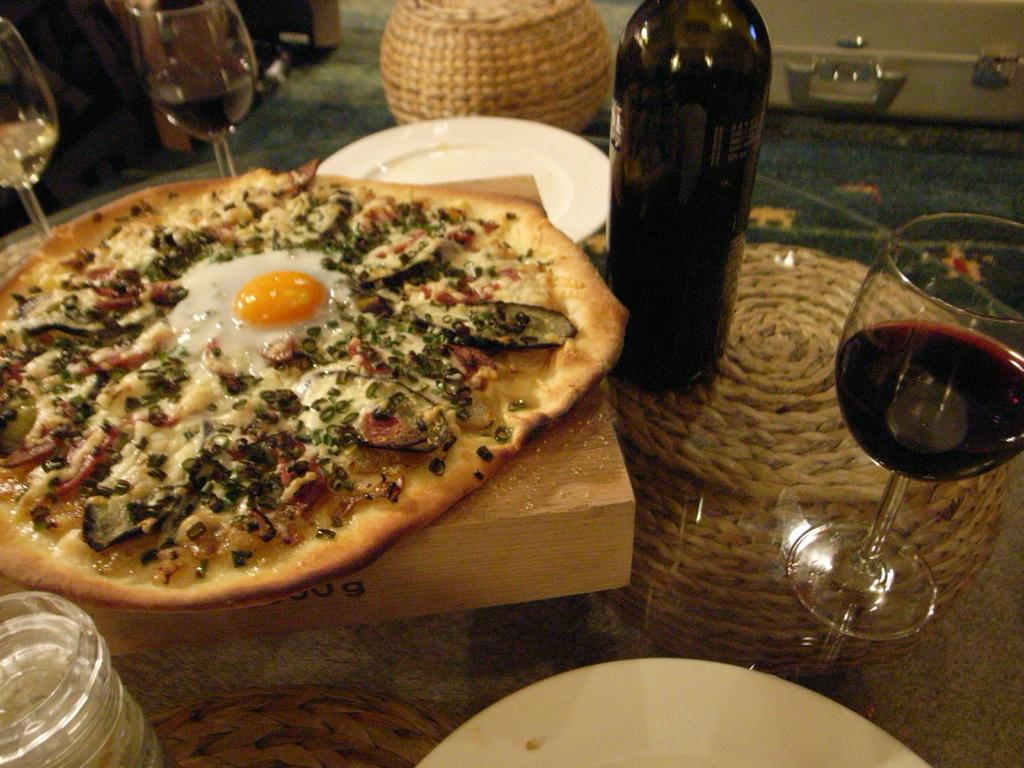What piece of furniture is present in the image? There is a table in the image. What is placed on the table? The table contains food on a wooden block, plates, glasses, and a bottle. What type of seating is available in the image? There is a stool on the floor. What type of cord can be seen connecting the land and the road in the image? There is no cord, land, or road present in the image. 